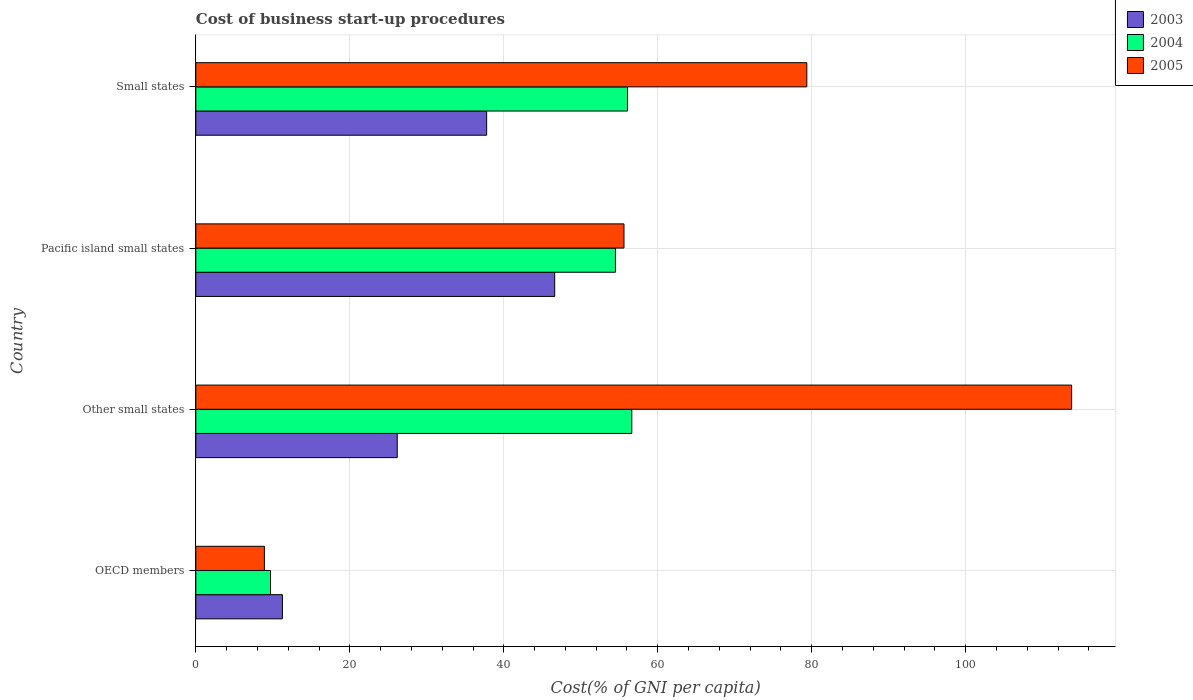How many different coloured bars are there?
Your answer should be very brief. 3. Are the number of bars on each tick of the Y-axis equal?
Offer a terse response. Yes. What is the label of the 2nd group of bars from the top?
Provide a short and direct response. Pacific island small states. In how many cases, is the number of bars for a given country not equal to the number of legend labels?
Give a very brief answer. 0. What is the cost of business start-up procedures in 2003 in OECD members?
Offer a terse response. 11.24. Across all countries, what is the maximum cost of business start-up procedures in 2003?
Your answer should be compact. 46.61. Across all countries, what is the minimum cost of business start-up procedures in 2003?
Your answer should be very brief. 11.24. In which country was the cost of business start-up procedures in 2003 maximum?
Your response must be concise. Pacific island small states. What is the total cost of business start-up procedures in 2003 in the graph?
Make the answer very short. 121.79. What is the difference between the cost of business start-up procedures in 2003 in OECD members and that in Pacific island small states?
Offer a very short reply. -35.37. What is the difference between the cost of business start-up procedures in 2004 in Other small states and the cost of business start-up procedures in 2003 in Small states?
Your answer should be compact. 18.85. What is the average cost of business start-up procedures in 2003 per country?
Offer a terse response. 30.45. What is the difference between the cost of business start-up procedures in 2003 and cost of business start-up procedures in 2005 in Other small states?
Make the answer very short. -87.59. In how many countries, is the cost of business start-up procedures in 2003 greater than 24 %?
Your response must be concise. 3. What is the ratio of the cost of business start-up procedures in 2005 in Other small states to that in Small states?
Give a very brief answer. 1.43. Is the difference between the cost of business start-up procedures in 2003 in Pacific island small states and Small states greater than the difference between the cost of business start-up procedures in 2005 in Pacific island small states and Small states?
Make the answer very short. Yes. What is the difference between the highest and the second highest cost of business start-up procedures in 2004?
Offer a very short reply. 0.56. What is the difference between the highest and the lowest cost of business start-up procedures in 2003?
Your answer should be very brief. 35.37. In how many countries, is the cost of business start-up procedures in 2003 greater than the average cost of business start-up procedures in 2003 taken over all countries?
Your answer should be very brief. 2. What does the 1st bar from the top in Pacific island small states represents?
Offer a very short reply. 2005. What does the 3rd bar from the bottom in Pacific island small states represents?
Offer a terse response. 2005. How many bars are there?
Your answer should be very brief. 12. Are all the bars in the graph horizontal?
Give a very brief answer. Yes. Does the graph contain any zero values?
Keep it short and to the point. No. Where does the legend appear in the graph?
Keep it short and to the point. Top right. How many legend labels are there?
Your response must be concise. 3. How are the legend labels stacked?
Your answer should be compact. Vertical. What is the title of the graph?
Make the answer very short. Cost of business start-up procedures. Does "2014" appear as one of the legend labels in the graph?
Your answer should be very brief. No. What is the label or title of the X-axis?
Your response must be concise. Cost(% of GNI per capita). What is the Cost(% of GNI per capita) of 2003 in OECD members?
Give a very brief answer. 11.24. What is the Cost(% of GNI per capita) in 2004 in OECD members?
Give a very brief answer. 9.7. What is the Cost(% of GNI per capita) of 2005 in OECD members?
Provide a short and direct response. 8.9. What is the Cost(% of GNI per capita) of 2003 in Other small states?
Offer a very short reply. 26.16. What is the Cost(% of GNI per capita) of 2004 in Other small states?
Ensure brevity in your answer.  56.62. What is the Cost(% of GNI per capita) of 2005 in Other small states?
Your answer should be compact. 113.75. What is the Cost(% of GNI per capita) of 2003 in Pacific island small states?
Provide a succinct answer. 46.61. What is the Cost(% of GNI per capita) in 2004 in Pacific island small states?
Provide a short and direct response. 54.5. What is the Cost(% of GNI per capita) of 2005 in Pacific island small states?
Give a very brief answer. 55.61. What is the Cost(% of GNI per capita) of 2003 in Small states?
Your response must be concise. 37.77. What is the Cost(% of GNI per capita) of 2004 in Small states?
Your answer should be compact. 56.07. What is the Cost(% of GNI per capita) in 2005 in Small states?
Your response must be concise. 79.36. Across all countries, what is the maximum Cost(% of GNI per capita) of 2003?
Provide a succinct answer. 46.61. Across all countries, what is the maximum Cost(% of GNI per capita) in 2004?
Your answer should be compact. 56.62. Across all countries, what is the maximum Cost(% of GNI per capita) of 2005?
Provide a short and direct response. 113.75. Across all countries, what is the minimum Cost(% of GNI per capita) of 2003?
Provide a succinct answer. 11.24. Across all countries, what is the minimum Cost(% of GNI per capita) of 2004?
Your answer should be compact. 9.7. Across all countries, what is the minimum Cost(% of GNI per capita) of 2005?
Your answer should be compact. 8.9. What is the total Cost(% of GNI per capita) in 2003 in the graph?
Make the answer very short. 121.79. What is the total Cost(% of GNI per capita) of 2004 in the graph?
Provide a succinct answer. 176.9. What is the total Cost(% of GNI per capita) in 2005 in the graph?
Ensure brevity in your answer.  257.62. What is the difference between the Cost(% of GNI per capita) in 2003 in OECD members and that in Other small states?
Offer a very short reply. -14.92. What is the difference between the Cost(% of GNI per capita) of 2004 in OECD members and that in Other small states?
Provide a short and direct response. -46.92. What is the difference between the Cost(% of GNI per capita) in 2005 in OECD members and that in Other small states?
Give a very brief answer. -104.85. What is the difference between the Cost(% of GNI per capita) of 2003 in OECD members and that in Pacific island small states?
Your answer should be compact. -35.37. What is the difference between the Cost(% of GNI per capita) in 2004 in OECD members and that in Pacific island small states?
Your answer should be very brief. -44.8. What is the difference between the Cost(% of GNI per capita) of 2005 in OECD members and that in Pacific island small states?
Provide a short and direct response. -46.71. What is the difference between the Cost(% of GNI per capita) in 2003 in OECD members and that in Small states?
Ensure brevity in your answer.  -26.53. What is the difference between the Cost(% of GNI per capita) of 2004 in OECD members and that in Small states?
Give a very brief answer. -46.37. What is the difference between the Cost(% of GNI per capita) of 2005 in OECD members and that in Small states?
Make the answer very short. -70.45. What is the difference between the Cost(% of GNI per capita) in 2003 in Other small states and that in Pacific island small states?
Give a very brief answer. -20.45. What is the difference between the Cost(% of GNI per capita) of 2004 in Other small states and that in Pacific island small states?
Offer a terse response. 2.12. What is the difference between the Cost(% of GNI per capita) of 2005 in Other small states and that in Pacific island small states?
Ensure brevity in your answer.  58.14. What is the difference between the Cost(% of GNI per capita) in 2003 in Other small states and that in Small states?
Provide a succinct answer. -11.61. What is the difference between the Cost(% of GNI per capita) of 2004 in Other small states and that in Small states?
Offer a terse response. 0.56. What is the difference between the Cost(% of GNI per capita) in 2005 in Other small states and that in Small states?
Your answer should be very brief. 34.4. What is the difference between the Cost(% of GNI per capita) in 2003 in Pacific island small states and that in Small states?
Provide a succinct answer. 8.84. What is the difference between the Cost(% of GNI per capita) of 2004 in Pacific island small states and that in Small states?
Your answer should be compact. -1.57. What is the difference between the Cost(% of GNI per capita) of 2005 in Pacific island small states and that in Small states?
Keep it short and to the point. -23.75. What is the difference between the Cost(% of GNI per capita) of 2003 in OECD members and the Cost(% of GNI per capita) of 2004 in Other small states?
Offer a very short reply. -45.38. What is the difference between the Cost(% of GNI per capita) in 2003 in OECD members and the Cost(% of GNI per capita) in 2005 in Other small states?
Make the answer very short. -102.51. What is the difference between the Cost(% of GNI per capita) of 2004 in OECD members and the Cost(% of GNI per capita) of 2005 in Other small states?
Keep it short and to the point. -104.05. What is the difference between the Cost(% of GNI per capita) of 2003 in OECD members and the Cost(% of GNI per capita) of 2004 in Pacific island small states?
Your answer should be very brief. -43.26. What is the difference between the Cost(% of GNI per capita) of 2003 in OECD members and the Cost(% of GNI per capita) of 2005 in Pacific island small states?
Provide a short and direct response. -44.37. What is the difference between the Cost(% of GNI per capita) in 2004 in OECD members and the Cost(% of GNI per capita) in 2005 in Pacific island small states?
Your answer should be compact. -45.91. What is the difference between the Cost(% of GNI per capita) in 2003 in OECD members and the Cost(% of GNI per capita) in 2004 in Small states?
Your answer should be compact. -44.82. What is the difference between the Cost(% of GNI per capita) in 2003 in OECD members and the Cost(% of GNI per capita) in 2005 in Small states?
Your response must be concise. -68.11. What is the difference between the Cost(% of GNI per capita) in 2004 in OECD members and the Cost(% of GNI per capita) in 2005 in Small states?
Keep it short and to the point. -69.65. What is the difference between the Cost(% of GNI per capita) of 2003 in Other small states and the Cost(% of GNI per capita) of 2004 in Pacific island small states?
Give a very brief answer. -28.34. What is the difference between the Cost(% of GNI per capita) in 2003 in Other small states and the Cost(% of GNI per capita) in 2005 in Pacific island small states?
Offer a very short reply. -29.45. What is the difference between the Cost(% of GNI per capita) of 2004 in Other small states and the Cost(% of GNI per capita) of 2005 in Pacific island small states?
Your answer should be compact. 1.01. What is the difference between the Cost(% of GNI per capita) in 2003 in Other small states and the Cost(% of GNI per capita) in 2004 in Small states?
Ensure brevity in your answer.  -29.91. What is the difference between the Cost(% of GNI per capita) in 2003 in Other small states and the Cost(% of GNI per capita) in 2005 in Small states?
Provide a short and direct response. -53.2. What is the difference between the Cost(% of GNI per capita) in 2004 in Other small states and the Cost(% of GNI per capita) in 2005 in Small states?
Your response must be concise. -22.73. What is the difference between the Cost(% of GNI per capita) of 2003 in Pacific island small states and the Cost(% of GNI per capita) of 2004 in Small states?
Your answer should be very brief. -9.46. What is the difference between the Cost(% of GNI per capita) in 2003 in Pacific island small states and the Cost(% of GNI per capita) in 2005 in Small states?
Give a very brief answer. -32.75. What is the difference between the Cost(% of GNI per capita) in 2004 in Pacific island small states and the Cost(% of GNI per capita) in 2005 in Small states?
Make the answer very short. -24.86. What is the average Cost(% of GNI per capita) of 2003 per country?
Make the answer very short. 30.45. What is the average Cost(% of GNI per capita) in 2004 per country?
Offer a very short reply. 44.22. What is the average Cost(% of GNI per capita) of 2005 per country?
Ensure brevity in your answer.  64.41. What is the difference between the Cost(% of GNI per capita) of 2003 and Cost(% of GNI per capita) of 2004 in OECD members?
Your response must be concise. 1.54. What is the difference between the Cost(% of GNI per capita) of 2003 and Cost(% of GNI per capita) of 2005 in OECD members?
Ensure brevity in your answer.  2.34. What is the difference between the Cost(% of GNI per capita) of 2003 and Cost(% of GNI per capita) of 2004 in Other small states?
Your answer should be compact. -30.46. What is the difference between the Cost(% of GNI per capita) of 2003 and Cost(% of GNI per capita) of 2005 in Other small states?
Offer a terse response. -87.59. What is the difference between the Cost(% of GNI per capita) in 2004 and Cost(% of GNI per capita) in 2005 in Other small states?
Keep it short and to the point. -57.13. What is the difference between the Cost(% of GNI per capita) in 2003 and Cost(% of GNI per capita) in 2004 in Pacific island small states?
Offer a terse response. -7.89. What is the difference between the Cost(% of GNI per capita) of 2003 and Cost(% of GNI per capita) of 2005 in Pacific island small states?
Your response must be concise. -9. What is the difference between the Cost(% of GNI per capita) of 2004 and Cost(% of GNI per capita) of 2005 in Pacific island small states?
Provide a succinct answer. -1.11. What is the difference between the Cost(% of GNI per capita) of 2003 and Cost(% of GNI per capita) of 2004 in Small states?
Offer a very short reply. -18.3. What is the difference between the Cost(% of GNI per capita) of 2003 and Cost(% of GNI per capita) of 2005 in Small states?
Provide a short and direct response. -41.58. What is the difference between the Cost(% of GNI per capita) of 2004 and Cost(% of GNI per capita) of 2005 in Small states?
Your response must be concise. -23.29. What is the ratio of the Cost(% of GNI per capita) in 2003 in OECD members to that in Other small states?
Give a very brief answer. 0.43. What is the ratio of the Cost(% of GNI per capita) of 2004 in OECD members to that in Other small states?
Your answer should be very brief. 0.17. What is the ratio of the Cost(% of GNI per capita) in 2005 in OECD members to that in Other small states?
Keep it short and to the point. 0.08. What is the ratio of the Cost(% of GNI per capita) in 2003 in OECD members to that in Pacific island small states?
Make the answer very short. 0.24. What is the ratio of the Cost(% of GNI per capita) of 2004 in OECD members to that in Pacific island small states?
Offer a very short reply. 0.18. What is the ratio of the Cost(% of GNI per capita) of 2005 in OECD members to that in Pacific island small states?
Your answer should be compact. 0.16. What is the ratio of the Cost(% of GNI per capita) of 2003 in OECD members to that in Small states?
Provide a short and direct response. 0.3. What is the ratio of the Cost(% of GNI per capita) in 2004 in OECD members to that in Small states?
Make the answer very short. 0.17. What is the ratio of the Cost(% of GNI per capita) in 2005 in OECD members to that in Small states?
Provide a short and direct response. 0.11. What is the ratio of the Cost(% of GNI per capita) of 2003 in Other small states to that in Pacific island small states?
Offer a very short reply. 0.56. What is the ratio of the Cost(% of GNI per capita) in 2004 in Other small states to that in Pacific island small states?
Your answer should be compact. 1.04. What is the ratio of the Cost(% of GNI per capita) of 2005 in Other small states to that in Pacific island small states?
Provide a succinct answer. 2.05. What is the ratio of the Cost(% of GNI per capita) in 2003 in Other small states to that in Small states?
Offer a very short reply. 0.69. What is the ratio of the Cost(% of GNI per capita) of 2004 in Other small states to that in Small states?
Provide a succinct answer. 1.01. What is the ratio of the Cost(% of GNI per capita) of 2005 in Other small states to that in Small states?
Make the answer very short. 1.43. What is the ratio of the Cost(% of GNI per capita) of 2003 in Pacific island small states to that in Small states?
Offer a very short reply. 1.23. What is the ratio of the Cost(% of GNI per capita) of 2005 in Pacific island small states to that in Small states?
Ensure brevity in your answer.  0.7. What is the difference between the highest and the second highest Cost(% of GNI per capita) of 2003?
Offer a terse response. 8.84. What is the difference between the highest and the second highest Cost(% of GNI per capita) in 2004?
Give a very brief answer. 0.56. What is the difference between the highest and the second highest Cost(% of GNI per capita) of 2005?
Your answer should be very brief. 34.4. What is the difference between the highest and the lowest Cost(% of GNI per capita) in 2003?
Make the answer very short. 35.37. What is the difference between the highest and the lowest Cost(% of GNI per capita) in 2004?
Provide a succinct answer. 46.92. What is the difference between the highest and the lowest Cost(% of GNI per capita) of 2005?
Provide a succinct answer. 104.85. 